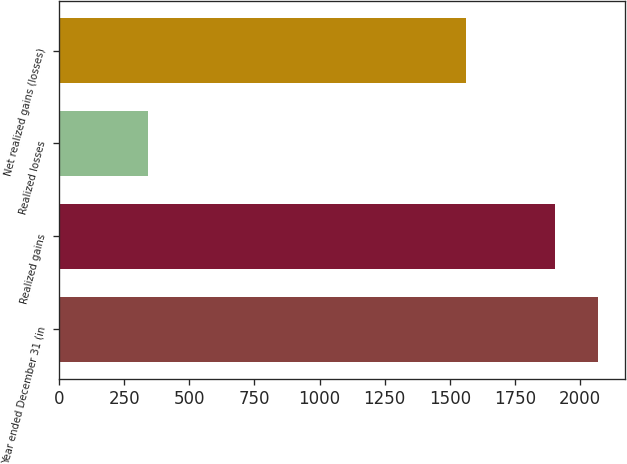Convert chart. <chart><loc_0><loc_0><loc_500><loc_500><bar_chart><fcel>Year ended December 31 (in<fcel>Realized gains<fcel>Realized losses<fcel>Net realized gains (losses)<nl><fcel>2070.1<fcel>1904<fcel>341<fcel>1563<nl></chart> 